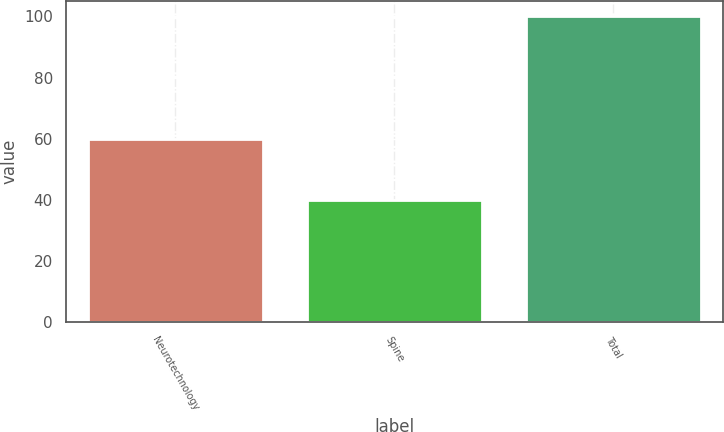Convert chart. <chart><loc_0><loc_0><loc_500><loc_500><bar_chart><fcel>Neurotechnology<fcel>Spine<fcel>Total<nl><fcel>60<fcel>40<fcel>100<nl></chart> 